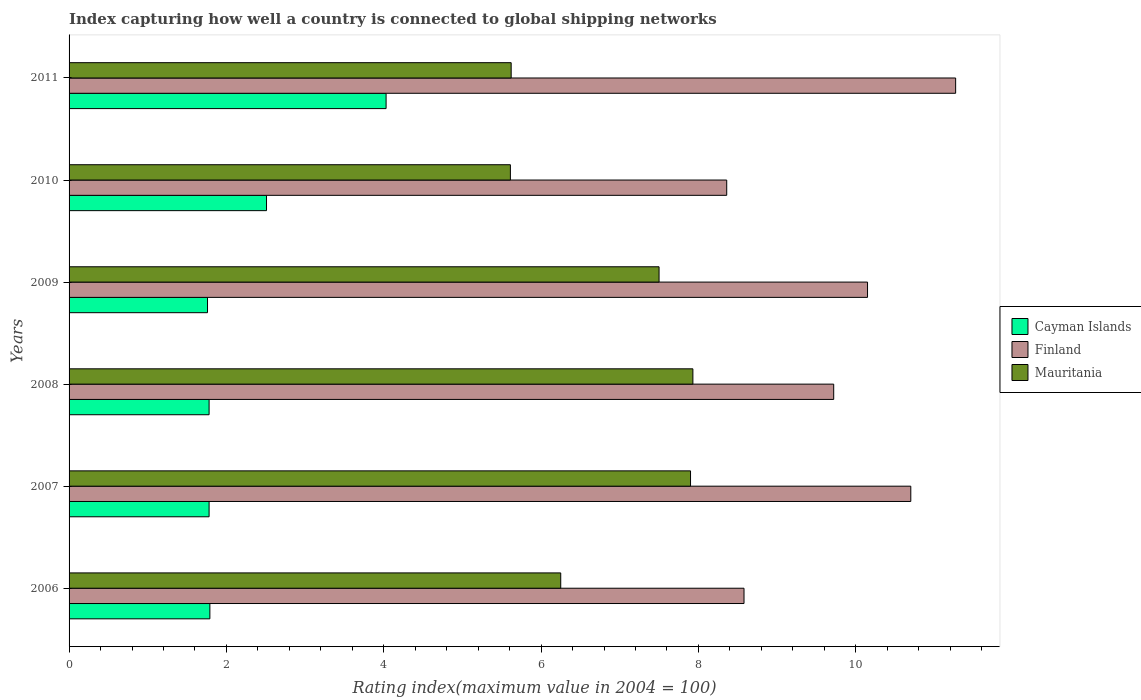How many groups of bars are there?
Give a very brief answer. 6. Are the number of bars on each tick of the Y-axis equal?
Make the answer very short. Yes. How many bars are there on the 5th tick from the top?
Your answer should be very brief. 3. In how many cases, is the number of bars for a given year not equal to the number of legend labels?
Give a very brief answer. 0. What is the rating index in Finland in 2009?
Your answer should be compact. 10.15. Across all years, what is the maximum rating index in Cayman Islands?
Make the answer very short. 4.03. Across all years, what is the minimum rating index in Finland?
Your answer should be compact. 8.36. What is the total rating index in Mauritania in the graph?
Provide a succinct answer. 40.81. What is the difference between the rating index in Mauritania in 2007 and that in 2008?
Your answer should be compact. -0.03. What is the difference between the rating index in Finland in 2006 and the rating index in Mauritania in 2010?
Provide a short and direct response. 2.97. What is the average rating index in Finland per year?
Your answer should be compact. 9.8. In the year 2007, what is the difference between the rating index in Mauritania and rating index in Cayman Islands?
Your answer should be compact. 6.12. What is the ratio of the rating index in Cayman Islands in 2008 to that in 2011?
Ensure brevity in your answer.  0.44. What is the difference between the highest and the second highest rating index in Mauritania?
Your answer should be very brief. 0.03. What is the difference between the highest and the lowest rating index in Mauritania?
Give a very brief answer. 2.32. In how many years, is the rating index in Finland greater than the average rating index in Finland taken over all years?
Give a very brief answer. 3. What does the 1st bar from the top in 2006 represents?
Your answer should be compact. Mauritania. What does the 3rd bar from the bottom in 2007 represents?
Provide a succinct answer. Mauritania. Is it the case that in every year, the sum of the rating index in Cayman Islands and rating index in Finland is greater than the rating index in Mauritania?
Provide a succinct answer. Yes. How many bars are there?
Ensure brevity in your answer.  18. Are all the bars in the graph horizontal?
Provide a succinct answer. Yes. Are the values on the major ticks of X-axis written in scientific E-notation?
Provide a succinct answer. No. Does the graph contain any zero values?
Provide a short and direct response. No. Where does the legend appear in the graph?
Ensure brevity in your answer.  Center right. How are the legend labels stacked?
Your answer should be very brief. Vertical. What is the title of the graph?
Your answer should be compact. Index capturing how well a country is connected to global shipping networks. Does "Czech Republic" appear as one of the legend labels in the graph?
Make the answer very short. No. What is the label or title of the X-axis?
Keep it short and to the point. Rating index(maximum value in 2004 = 100). What is the label or title of the Y-axis?
Offer a terse response. Years. What is the Rating index(maximum value in 2004 = 100) in Cayman Islands in 2006?
Give a very brief answer. 1.79. What is the Rating index(maximum value in 2004 = 100) in Finland in 2006?
Your answer should be very brief. 8.58. What is the Rating index(maximum value in 2004 = 100) of Mauritania in 2006?
Your answer should be very brief. 6.25. What is the Rating index(maximum value in 2004 = 100) in Cayman Islands in 2007?
Offer a very short reply. 1.78. What is the Rating index(maximum value in 2004 = 100) of Finland in 2007?
Ensure brevity in your answer.  10.7. What is the Rating index(maximum value in 2004 = 100) of Cayman Islands in 2008?
Provide a succinct answer. 1.78. What is the Rating index(maximum value in 2004 = 100) of Finland in 2008?
Your response must be concise. 9.72. What is the Rating index(maximum value in 2004 = 100) in Mauritania in 2008?
Offer a terse response. 7.93. What is the Rating index(maximum value in 2004 = 100) of Cayman Islands in 2009?
Provide a short and direct response. 1.76. What is the Rating index(maximum value in 2004 = 100) in Finland in 2009?
Make the answer very short. 10.15. What is the Rating index(maximum value in 2004 = 100) in Cayman Islands in 2010?
Your answer should be compact. 2.51. What is the Rating index(maximum value in 2004 = 100) of Finland in 2010?
Keep it short and to the point. 8.36. What is the Rating index(maximum value in 2004 = 100) of Mauritania in 2010?
Your answer should be compact. 5.61. What is the Rating index(maximum value in 2004 = 100) in Cayman Islands in 2011?
Your response must be concise. 4.03. What is the Rating index(maximum value in 2004 = 100) in Finland in 2011?
Make the answer very short. 11.27. What is the Rating index(maximum value in 2004 = 100) in Mauritania in 2011?
Your answer should be compact. 5.62. Across all years, what is the maximum Rating index(maximum value in 2004 = 100) in Cayman Islands?
Your response must be concise. 4.03. Across all years, what is the maximum Rating index(maximum value in 2004 = 100) of Finland?
Provide a short and direct response. 11.27. Across all years, what is the maximum Rating index(maximum value in 2004 = 100) of Mauritania?
Provide a succinct answer. 7.93. Across all years, what is the minimum Rating index(maximum value in 2004 = 100) in Cayman Islands?
Your answer should be very brief. 1.76. Across all years, what is the minimum Rating index(maximum value in 2004 = 100) of Finland?
Offer a terse response. 8.36. Across all years, what is the minimum Rating index(maximum value in 2004 = 100) of Mauritania?
Your response must be concise. 5.61. What is the total Rating index(maximum value in 2004 = 100) in Cayman Islands in the graph?
Give a very brief answer. 13.65. What is the total Rating index(maximum value in 2004 = 100) in Finland in the graph?
Offer a terse response. 58.78. What is the total Rating index(maximum value in 2004 = 100) of Mauritania in the graph?
Keep it short and to the point. 40.81. What is the difference between the Rating index(maximum value in 2004 = 100) of Cayman Islands in 2006 and that in 2007?
Offer a very short reply. 0.01. What is the difference between the Rating index(maximum value in 2004 = 100) in Finland in 2006 and that in 2007?
Your answer should be very brief. -2.12. What is the difference between the Rating index(maximum value in 2004 = 100) of Mauritania in 2006 and that in 2007?
Give a very brief answer. -1.65. What is the difference between the Rating index(maximum value in 2004 = 100) in Finland in 2006 and that in 2008?
Your answer should be compact. -1.14. What is the difference between the Rating index(maximum value in 2004 = 100) in Mauritania in 2006 and that in 2008?
Offer a terse response. -1.68. What is the difference between the Rating index(maximum value in 2004 = 100) in Finland in 2006 and that in 2009?
Provide a short and direct response. -1.57. What is the difference between the Rating index(maximum value in 2004 = 100) in Mauritania in 2006 and that in 2009?
Give a very brief answer. -1.25. What is the difference between the Rating index(maximum value in 2004 = 100) in Cayman Islands in 2006 and that in 2010?
Provide a succinct answer. -0.72. What is the difference between the Rating index(maximum value in 2004 = 100) of Finland in 2006 and that in 2010?
Provide a succinct answer. 0.22. What is the difference between the Rating index(maximum value in 2004 = 100) in Mauritania in 2006 and that in 2010?
Ensure brevity in your answer.  0.64. What is the difference between the Rating index(maximum value in 2004 = 100) in Cayman Islands in 2006 and that in 2011?
Make the answer very short. -2.24. What is the difference between the Rating index(maximum value in 2004 = 100) in Finland in 2006 and that in 2011?
Give a very brief answer. -2.69. What is the difference between the Rating index(maximum value in 2004 = 100) of Mauritania in 2006 and that in 2011?
Your answer should be very brief. 0.63. What is the difference between the Rating index(maximum value in 2004 = 100) in Cayman Islands in 2007 and that in 2008?
Your answer should be compact. 0. What is the difference between the Rating index(maximum value in 2004 = 100) of Finland in 2007 and that in 2008?
Ensure brevity in your answer.  0.98. What is the difference between the Rating index(maximum value in 2004 = 100) of Mauritania in 2007 and that in 2008?
Provide a short and direct response. -0.03. What is the difference between the Rating index(maximum value in 2004 = 100) of Finland in 2007 and that in 2009?
Your answer should be very brief. 0.55. What is the difference between the Rating index(maximum value in 2004 = 100) in Cayman Islands in 2007 and that in 2010?
Keep it short and to the point. -0.73. What is the difference between the Rating index(maximum value in 2004 = 100) of Finland in 2007 and that in 2010?
Provide a short and direct response. 2.34. What is the difference between the Rating index(maximum value in 2004 = 100) of Mauritania in 2007 and that in 2010?
Your answer should be very brief. 2.29. What is the difference between the Rating index(maximum value in 2004 = 100) in Cayman Islands in 2007 and that in 2011?
Give a very brief answer. -2.25. What is the difference between the Rating index(maximum value in 2004 = 100) of Finland in 2007 and that in 2011?
Provide a short and direct response. -0.57. What is the difference between the Rating index(maximum value in 2004 = 100) of Mauritania in 2007 and that in 2011?
Your response must be concise. 2.28. What is the difference between the Rating index(maximum value in 2004 = 100) of Cayman Islands in 2008 and that in 2009?
Make the answer very short. 0.02. What is the difference between the Rating index(maximum value in 2004 = 100) in Finland in 2008 and that in 2009?
Your response must be concise. -0.43. What is the difference between the Rating index(maximum value in 2004 = 100) in Mauritania in 2008 and that in 2009?
Offer a terse response. 0.43. What is the difference between the Rating index(maximum value in 2004 = 100) of Cayman Islands in 2008 and that in 2010?
Give a very brief answer. -0.73. What is the difference between the Rating index(maximum value in 2004 = 100) in Finland in 2008 and that in 2010?
Keep it short and to the point. 1.36. What is the difference between the Rating index(maximum value in 2004 = 100) of Mauritania in 2008 and that in 2010?
Give a very brief answer. 2.32. What is the difference between the Rating index(maximum value in 2004 = 100) in Cayman Islands in 2008 and that in 2011?
Provide a succinct answer. -2.25. What is the difference between the Rating index(maximum value in 2004 = 100) of Finland in 2008 and that in 2011?
Ensure brevity in your answer.  -1.55. What is the difference between the Rating index(maximum value in 2004 = 100) in Mauritania in 2008 and that in 2011?
Give a very brief answer. 2.31. What is the difference between the Rating index(maximum value in 2004 = 100) of Cayman Islands in 2009 and that in 2010?
Offer a terse response. -0.75. What is the difference between the Rating index(maximum value in 2004 = 100) in Finland in 2009 and that in 2010?
Your answer should be very brief. 1.79. What is the difference between the Rating index(maximum value in 2004 = 100) in Mauritania in 2009 and that in 2010?
Your response must be concise. 1.89. What is the difference between the Rating index(maximum value in 2004 = 100) in Cayman Islands in 2009 and that in 2011?
Provide a succinct answer. -2.27. What is the difference between the Rating index(maximum value in 2004 = 100) of Finland in 2009 and that in 2011?
Your answer should be very brief. -1.12. What is the difference between the Rating index(maximum value in 2004 = 100) in Mauritania in 2009 and that in 2011?
Keep it short and to the point. 1.88. What is the difference between the Rating index(maximum value in 2004 = 100) of Cayman Islands in 2010 and that in 2011?
Your response must be concise. -1.52. What is the difference between the Rating index(maximum value in 2004 = 100) of Finland in 2010 and that in 2011?
Your answer should be very brief. -2.91. What is the difference between the Rating index(maximum value in 2004 = 100) of Mauritania in 2010 and that in 2011?
Your response must be concise. -0.01. What is the difference between the Rating index(maximum value in 2004 = 100) in Cayman Islands in 2006 and the Rating index(maximum value in 2004 = 100) in Finland in 2007?
Ensure brevity in your answer.  -8.91. What is the difference between the Rating index(maximum value in 2004 = 100) in Cayman Islands in 2006 and the Rating index(maximum value in 2004 = 100) in Mauritania in 2007?
Offer a very short reply. -6.11. What is the difference between the Rating index(maximum value in 2004 = 100) in Finland in 2006 and the Rating index(maximum value in 2004 = 100) in Mauritania in 2007?
Ensure brevity in your answer.  0.68. What is the difference between the Rating index(maximum value in 2004 = 100) of Cayman Islands in 2006 and the Rating index(maximum value in 2004 = 100) of Finland in 2008?
Give a very brief answer. -7.93. What is the difference between the Rating index(maximum value in 2004 = 100) in Cayman Islands in 2006 and the Rating index(maximum value in 2004 = 100) in Mauritania in 2008?
Keep it short and to the point. -6.14. What is the difference between the Rating index(maximum value in 2004 = 100) of Finland in 2006 and the Rating index(maximum value in 2004 = 100) of Mauritania in 2008?
Your response must be concise. 0.65. What is the difference between the Rating index(maximum value in 2004 = 100) in Cayman Islands in 2006 and the Rating index(maximum value in 2004 = 100) in Finland in 2009?
Offer a terse response. -8.36. What is the difference between the Rating index(maximum value in 2004 = 100) of Cayman Islands in 2006 and the Rating index(maximum value in 2004 = 100) of Mauritania in 2009?
Offer a very short reply. -5.71. What is the difference between the Rating index(maximum value in 2004 = 100) of Finland in 2006 and the Rating index(maximum value in 2004 = 100) of Mauritania in 2009?
Keep it short and to the point. 1.08. What is the difference between the Rating index(maximum value in 2004 = 100) in Cayman Islands in 2006 and the Rating index(maximum value in 2004 = 100) in Finland in 2010?
Provide a succinct answer. -6.57. What is the difference between the Rating index(maximum value in 2004 = 100) of Cayman Islands in 2006 and the Rating index(maximum value in 2004 = 100) of Mauritania in 2010?
Your answer should be very brief. -3.82. What is the difference between the Rating index(maximum value in 2004 = 100) of Finland in 2006 and the Rating index(maximum value in 2004 = 100) of Mauritania in 2010?
Keep it short and to the point. 2.97. What is the difference between the Rating index(maximum value in 2004 = 100) in Cayman Islands in 2006 and the Rating index(maximum value in 2004 = 100) in Finland in 2011?
Keep it short and to the point. -9.48. What is the difference between the Rating index(maximum value in 2004 = 100) of Cayman Islands in 2006 and the Rating index(maximum value in 2004 = 100) of Mauritania in 2011?
Your answer should be very brief. -3.83. What is the difference between the Rating index(maximum value in 2004 = 100) in Finland in 2006 and the Rating index(maximum value in 2004 = 100) in Mauritania in 2011?
Your answer should be very brief. 2.96. What is the difference between the Rating index(maximum value in 2004 = 100) of Cayman Islands in 2007 and the Rating index(maximum value in 2004 = 100) of Finland in 2008?
Keep it short and to the point. -7.94. What is the difference between the Rating index(maximum value in 2004 = 100) in Cayman Islands in 2007 and the Rating index(maximum value in 2004 = 100) in Mauritania in 2008?
Ensure brevity in your answer.  -6.15. What is the difference between the Rating index(maximum value in 2004 = 100) in Finland in 2007 and the Rating index(maximum value in 2004 = 100) in Mauritania in 2008?
Offer a very short reply. 2.77. What is the difference between the Rating index(maximum value in 2004 = 100) in Cayman Islands in 2007 and the Rating index(maximum value in 2004 = 100) in Finland in 2009?
Keep it short and to the point. -8.37. What is the difference between the Rating index(maximum value in 2004 = 100) of Cayman Islands in 2007 and the Rating index(maximum value in 2004 = 100) of Mauritania in 2009?
Provide a short and direct response. -5.72. What is the difference between the Rating index(maximum value in 2004 = 100) of Finland in 2007 and the Rating index(maximum value in 2004 = 100) of Mauritania in 2009?
Give a very brief answer. 3.2. What is the difference between the Rating index(maximum value in 2004 = 100) of Cayman Islands in 2007 and the Rating index(maximum value in 2004 = 100) of Finland in 2010?
Your response must be concise. -6.58. What is the difference between the Rating index(maximum value in 2004 = 100) of Cayman Islands in 2007 and the Rating index(maximum value in 2004 = 100) of Mauritania in 2010?
Keep it short and to the point. -3.83. What is the difference between the Rating index(maximum value in 2004 = 100) of Finland in 2007 and the Rating index(maximum value in 2004 = 100) of Mauritania in 2010?
Your answer should be very brief. 5.09. What is the difference between the Rating index(maximum value in 2004 = 100) in Cayman Islands in 2007 and the Rating index(maximum value in 2004 = 100) in Finland in 2011?
Offer a terse response. -9.49. What is the difference between the Rating index(maximum value in 2004 = 100) in Cayman Islands in 2007 and the Rating index(maximum value in 2004 = 100) in Mauritania in 2011?
Ensure brevity in your answer.  -3.84. What is the difference between the Rating index(maximum value in 2004 = 100) of Finland in 2007 and the Rating index(maximum value in 2004 = 100) of Mauritania in 2011?
Offer a very short reply. 5.08. What is the difference between the Rating index(maximum value in 2004 = 100) of Cayman Islands in 2008 and the Rating index(maximum value in 2004 = 100) of Finland in 2009?
Offer a very short reply. -8.37. What is the difference between the Rating index(maximum value in 2004 = 100) in Cayman Islands in 2008 and the Rating index(maximum value in 2004 = 100) in Mauritania in 2009?
Provide a short and direct response. -5.72. What is the difference between the Rating index(maximum value in 2004 = 100) of Finland in 2008 and the Rating index(maximum value in 2004 = 100) of Mauritania in 2009?
Make the answer very short. 2.22. What is the difference between the Rating index(maximum value in 2004 = 100) of Cayman Islands in 2008 and the Rating index(maximum value in 2004 = 100) of Finland in 2010?
Keep it short and to the point. -6.58. What is the difference between the Rating index(maximum value in 2004 = 100) in Cayman Islands in 2008 and the Rating index(maximum value in 2004 = 100) in Mauritania in 2010?
Provide a succinct answer. -3.83. What is the difference between the Rating index(maximum value in 2004 = 100) in Finland in 2008 and the Rating index(maximum value in 2004 = 100) in Mauritania in 2010?
Your answer should be very brief. 4.11. What is the difference between the Rating index(maximum value in 2004 = 100) in Cayman Islands in 2008 and the Rating index(maximum value in 2004 = 100) in Finland in 2011?
Offer a terse response. -9.49. What is the difference between the Rating index(maximum value in 2004 = 100) in Cayman Islands in 2008 and the Rating index(maximum value in 2004 = 100) in Mauritania in 2011?
Your answer should be very brief. -3.84. What is the difference between the Rating index(maximum value in 2004 = 100) of Cayman Islands in 2009 and the Rating index(maximum value in 2004 = 100) of Finland in 2010?
Provide a short and direct response. -6.6. What is the difference between the Rating index(maximum value in 2004 = 100) of Cayman Islands in 2009 and the Rating index(maximum value in 2004 = 100) of Mauritania in 2010?
Provide a short and direct response. -3.85. What is the difference between the Rating index(maximum value in 2004 = 100) of Finland in 2009 and the Rating index(maximum value in 2004 = 100) of Mauritania in 2010?
Give a very brief answer. 4.54. What is the difference between the Rating index(maximum value in 2004 = 100) of Cayman Islands in 2009 and the Rating index(maximum value in 2004 = 100) of Finland in 2011?
Ensure brevity in your answer.  -9.51. What is the difference between the Rating index(maximum value in 2004 = 100) in Cayman Islands in 2009 and the Rating index(maximum value in 2004 = 100) in Mauritania in 2011?
Provide a short and direct response. -3.86. What is the difference between the Rating index(maximum value in 2004 = 100) in Finland in 2009 and the Rating index(maximum value in 2004 = 100) in Mauritania in 2011?
Give a very brief answer. 4.53. What is the difference between the Rating index(maximum value in 2004 = 100) of Cayman Islands in 2010 and the Rating index(maximum value in 2004 = 100) of Finland in 2011?
Ensure brevity in your answer.  -8.76. What is the difference between the Rating index(maximum value in 2004 = 100) of Cayman Islands in 2010 and the Rating index(maximum value in 2004 = 100) of Mauritania in 2011?
Offer a terse response. -3.11. What is the difference between the Rating index(maximum value in 2004 = 100) in Finland in 2010 and the Rating index(maximum value in 2004 = 100) in Mauritania in 2011?
Your response must be concise. 2.74. What is the average Rating index(maximum value in 2004 = 100) of Cayman Islands per year?
Keep it short and to the point. 2.27. What is the average Rating index(maximum value in 2004 = 100) in Finland per year?
Your response must be concise. 9.8. What is the average Rating index(maximum value in 2004 = 100) of Mauritania per year?
Offer a terse response. 6.8. In the year 2006, what is the difference between the Rating index(maximum value in 2004 = 100) of Cayman Islands and Rating index(maximum value in 2004 = 100) of Finland?
Provide a short and direct response. -6.79. In the year 2006, what is the difference between the Rating index(maximum value in 2004 = 100) of Cayman Islands and Rating index(maximum value in 2004 = 100) of Mauritania?
Offer a very short reply. -4.46. In the year 2006, what is the difference between the Rating index(maximum value in 2004 = 100) in Finland and Rating index(maximum value in 2004 = 100) in Mauritania?
Your answer should be compact. 2.33. In the year 2007, what is the difference between the Rating index(maximum value in 2004 = 100) of Cayman Islands and Rating index(maximum value in 2004 = 100) of Finland?
Give a very brief answer. -8.92. In the year 2007, what is the difference between the Rating index(maximum value in 2004 = 100) in Cayman Islands and Rating index(maximum value in 2004 = 100) in Mauritania?
Ensure brevity in your answer.  -6.12. In the year 2007, what is the difference between the Rating index(maximum value in 2004 = 100) of Finland and Rating index(maximum value in 2004 = 100) of Mauritania?
Offer a very short reply. 2.8. In the year 2008, what is the difference between the Rating index(maximum value in 2004 = 100) in Cayman Islands and Rating index(maximum value in 2004 = 100) in Finland?
Give a very brief answer. -7.94. In the year 2008, what is the difference between the Rating index(maximum value in 2004 = 100) of Cayman Islands and Rating index(maximum value in 2004 = 100) of Mauritania?
Provide a succinct answer. -6.15. In the year 2008, what is the difference between the Rating index(maximum value in 2004 = 100) of Finland and Rating index(maximum value in 2004 = 100) of Mauritania?
Provide a succinct answer. 1.79. In the year 2009, what is the difference between the Rating index(maximum value in 2004 = 100) in Cayman Islands and Rating index(maximum value in 2004 = 100) in Finland?
Offer a very short reply. -8.39. In the year 2009, what is the difference between the Rating index(maximum value in 2004 = 100) of Cayman Islands and Rating index(maximum value in 2004 = 100) of Mauritania?
Make the answer very short. -5.74. In the year 2009, what is the difference between the Rating index(maximum value in 2004 = 100) of Finland and Rating index(maximum value in 2004 = 100) of Mauritania?
Provide a succinct answer. 2.65. In the year 2010, what is the difference between the Rating index(maximum value in 2004 = 100) in Cayman Islands and Rating index(maximum value in 2004 = 100) in Finland?
Give a very brief answer. -5.85. In the year 2010, what is the difference between the Rating index(maximum value in 2004 = 100) of Cayman Islands and Rating index(maximum value in 2004 = 100) of Mauritania?
Your response must be concise. -3.1. In the year 2010, what is the difference between the Rating index(maximum value in 2004 = 100) in Finland and Rating index(maximum value in 2004 = 100) in Mauritania?
Your answer should be compact. 2.75. In the year 2011, what is the difference between the Rating index(maximum value in 2004 = 100) of Cayman Islands and Rating index(maximum value in 2004 = 100) of Finland?
Your response must be concise. -7.24. In the year 2011, what is the difference between the Rating index(maximum value in 2004 = 100) in Cayman Islands and Rating index(maximum value in 2004 = 100) in Mauritania?
Offer a terse response. -1.59. In the year 2011, what is the difference between the Rating index(maximum value in 2004 = 100) in Finland and Rating index(maximum value in 2004 = 100) in Mauritania?
Keep it short and to the point. 5.65. What is the ratio of the Rating index(maximum value in 2004 = 100) in Cayman Islands in 2006 to that in 2007?
Provide a short and direct response. 1.01. What is the ratio of the Rating index(maximum value in 2004 = 100) of Finland in 2006 to that in 2007?
Your answer should be very brief. 0.8. What is the ratio of the Rating index(maximum value in 2004 = 100) of Mauritania in 2006 to that in 2007?
Your response must be concise. 0.79. What is the ratio of the Rating index(maximum value in 2004 = 100) in Cayman Islands in 2006 to that in 2008?
Keep it short and to the point. 1.01. What is the ratio of the Rating index(maximum value in 2004 = 100) of Finland in 2006 to that in 2008?
Offer a very short reply. 0.88. What is the ratio of the Rating index(maximum value in 2004 = 100) of Mauritania in 2006 to that in 2008?
Offer a terse response. 0.79. What is the ratio of the Rating index(maximum value in 2004 = 100) of Finland in 2006 to that in 2009?
Give a very brief answer. 0.85. What is the ratio of the Rating index(maximum value in 2004 = 100) of Mauritania in 2006 to that in 2009?
Your answer should be compact. 0.83. What is the ratio of the Rating index(maximum value in 2004 = 100) in Cayman Islands in 2006 to that in 2010?
Your answer should be compact. 0.71. What is the ratio of the Rating index(maximum value in 2004 = 100) in Finland in 2006 to that in 2010?
Provide a succinct answer. 1.03. What is the ratio of the Rating index(maximum value in 2004 = 100) of Mauritania in 2006 to that in 2010?
Your response must be concise. 1.11. What is the ratio of the Rating index(maximum value in 2004 = 100) in Cayman Islands in 2006 to that in 2011?
Ensure brevity in your answer.  0.44. What is the ratio of the Rating index(maximum value in 2004 = 100) in Finland in 2006 to that in 2011?
Give a very brief answer. 0.76. What is the ratio of the Rating index(maximum value in 2004 = 100) of Mauritania in 2006 to that in 2011?
Provide a succinct answer. 1.11. What is the ratio of the Rating index(maximum value in 2004 = 100) in Finland in 2007 to that in 2008?
Provide a succinct answer. 1.1. What is the ratio of the Rating index(maximum value in 2004 = 100) of Cayman Islands in 2007 to that in 2009?
Your answer should be very brief. 1.01. What is the ratio of the Rating index(maximum value in 2004 = 100) of Finland in 2007 to that in 2009?
Provide a short and direct response. 1.05. What is the ratio of the Rating index(maximum value in 2004 = 100) of Mauritania in 2007 to that in 2009?
Your answer should be very brief. 1.05. What is the ratio of the Rating index(maximum value in 2004 = 100) in Cayman Islands in 2007 to that in 2010?
Your answer should be very brief. 0.71. What is the ratio of the Rating index(maximum value in 2004 = 100) of Finland in 2007 to that in 2010?
Offer a very short reply. 1.28. What is the ratio of the Rating index(maximum value in 2004 = 100) in Mauritania in 2007 to that in 2010?
Give a very brief answer. 1.41. What is the ratio of the Rating index(maximum value in 2004 = 100) of Cayman Islands in 2007 to that in 2011?
Provide a succinct answer. 0.44. What is the ratio of the Rating index(maximum value in 2004 = 100) of Finland in 2007 to that in 2011?
Offer a very short reply. 0.95. What is the ratio of the Rating index(maximum value in 2004 = 100) of Mauritania in 2007 to that in 2011?
Your response must be concise. 1.41. What is the ratio of the Rating index(maximum value in 2004 = 100) in Cayman Islands in 2008 to that in 2009?
Keep it short and to the point. 1.01. What is the ratio of the Rating index(maximum value in 2004 = 100) of Finland in 2008 to that in 2009?
Keep it short and to the point. 0.96. What is the ratio of the Rating index(maximum value in 2004 = 100) in Mauritania in 2008 to that in 2009?
Provide a short and direct response. 1.06. What is the ratio of the Rating index(maximum value in 2004 = 100) of Cayman Islands in 2008 to that in 2010?
Your answer should be very brief. 0.71. What is the ratio of the Rating index(maximum value in 2004 = 100) in Finland in 2008 to that in 2010?
Offer a terse response. 1.16. What is the ratio of the Rating index(maximum value in 2004 = 100) in Mauritania in 2008 to that in 2010?
Offer a terse response. 1.41. What is the ratio of the Rating index(maximum value in 2004 = 100) in Cayman Islands in 2008 to that in 2011?
Provide a short and direct response. 0.44. What is the ratio of the Rating index(maximum value in 2004 = 100) of Finland in 2008 to that in 2011?
Offer a very short reply. 0.86. What is the ratio of the Rating index(maximum value in 2004 = 100) in Mauritania in 2008 to that in 2011?
Offer a terse response. 1.41. What is the ratio of the Rating index(maximum value in 2004 = 100) in Cayman Islands in 2009 to that in 2010?
Keep it short and to the point. 0.7. What is the ratio of the Rating index(maximum value in 2004 = 100) in Finland in 2009 to that in 2010?
Provide a short and direct response. 1.21. What is the ratio of the Rating index(maximum value in 2004 = 100) in Mauritania in 2009 to that in 2010?
Provide a short and direct response. 1.34. What is the ratio of the Rating index(maximum value in 2004 = 100) in Cayman Islands in 2009 to that in 2011?
Your answer should be compact. 0.44. What is the ratio of the Rating index(maximum value in 2004 = 100) in Finland in 2009 to that in 2011?
Your answer should be compact. 0.9. What is the ratio of the Rating index(maximum value in 2004 = 100) of Mauritania in 2009 to that in 2011?
Ensure brevity in your answer.  1.33. What is the ratio of the Rating index(maximum value in 2004 = 100) of Cayman Islands in 2010 to that in 2011?
Make the answer very short. 0.62. What is the ratio of the Rating index(maximum value in 2004 = 100) in Finland in 2010 to that in 2011?
Offer a terse response. 0.74. What is the difference between the highest and the second highest Rating index(maximum value in 2004 = 100) of Cayman Islands?
Ensure brevity in your answer.  1.52. What is the difference between the highest and the second highest Rating index(maximum value in 2004 = 100) of Finland?
Offer a terse response. 0.57. What is the difference between the highest and the lowest Rating index(maximum value in 2004 = 100) of Cayman Islands?
Make the answer very short. 2.27. What is the difference between the highest and the lowest Rating index(maximum value in 2004 = 100) of Finland?
Your answer should be very brief. 2.91. What is the difference between the highest and the lowest Rating index(maximum value in 2004 = 100) in Mauritania?
Ensure brevity in your answer.  2.32. 